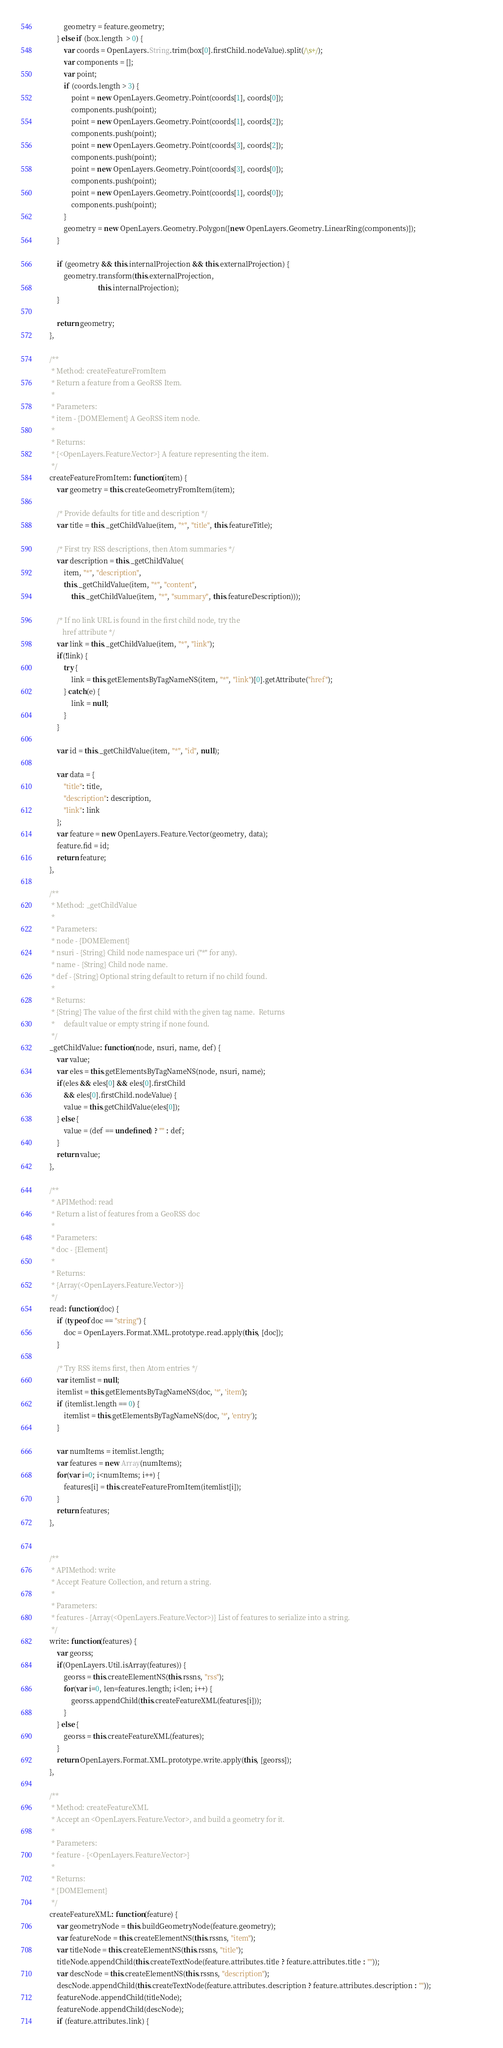<code> <loc_0><loc_0><loc_500><loc_500><_JavaScript_>            geometry = feature.geometry;
        } else if (box.length  > 0) {
            var coords = OpenLayers.String.trim(box[0].firstChild.nodeValue).split(/\s+/);
            var components = [];
            var point;
            if (coords.length > 3) {
                point = new OpenLayers.Geometry.Point(coords[1], coords[0]);
                components.push(point);
                point = new OpenLayers.Geometry.Point(coords[1], coords[2]);
                components.push(point);
                point = new OpenLayers.Geometry.Point(coords[3], coords[2]);
                components.push(point);
                point = new OpenLayers.Geometry.Point(coords[3], coords[0]);
                components.push(point);
                point = new OpenLayers.Geometry.Point(coords[1], coords[0]);
                components.push(point);
            }
            geometry = new OpenLayers.Geometry.Polygon([new OpenLayers.Geometry.LinearRing(components)]);									 
        }
        
        if (geometry && this.internalProjection && this.externalProjection) {
            geometry.transform(this.externalProjection, 
                               this.internalProjection);
        }

        return geometry;
    },        

    /**
     * Method: createFeatureFromItem
     * Return a feature from a GeoRSS Item.
     *
     * Parameters:
     * item - {DOMElement} A GeoRSS item node.
     *
     * Returns:
     * {<OpenLayers.Feature.Vector>} A feature representing the item.
     */
    createFeatureFromItem: function(item) {
        var geometry = this.createGeometryFromItem(item);
     
        /* Provide defaults for title and description */
        var title = this._getChildValue(item, "*", "title", this.featureTitle);
       
        /* First try RSS descriptions, then Atom summaries */
        var description = this._getChildValue(
            item, "*", "description",
            this._getChildValue(item, "*", "content",
                this._getChildValue(item, "*", "summary", this.featureDescription)));

        /* If no link URL is found in the first child node, try the
           href attribute */
        var link = this._getChildValue(item, "*", "link");
        if(!link) {
            try {
                link = this.getElementsByTagNameNS(item, "*", "link")[0].getAttribute("href");
            } catch(e) {
                link = null;
            }
        }

        var id = this._getChildValue(item, "*", "id", null);
        
        var data = {
            "title": title,
            "description": description,
            "link": link
        };
        var feature = new OpenLayers.Feature.Vector(geometry, data);
        feature.fid = id;
        return feature;
    },        
    
    /**
     * Method: _getChildValue
     *
     * Parameters:
     * node - {DOMElement}
     * nsuri - {String} Child node namespace uri ("*" for any).
     * name - {String} Child node name.
     * def - {String} Optional string default to return if no child found.
     *
     * Returns:
     * {String} The value of the first child with the given tag name.  Returns
     *     default value or empty string if none found.
     */
    _getChildValue: function(node, nsuri, name, def) {
        var value;
        var eles = this.getElementsByTagNameNS(node, nsuri, name);
        if(eles && eles[0] && eles[0].firstChild
            && eles[0].firstChild.nodeValue) {
            value = this.getChildValue(eles[0]);
        } else {
            value = (def == undefined) ? "" : def;
        }
        return value;
    },
    
    /**
     * APIMethod: read
     * Return a list of features from a GeoRSS doc
     *
     * Parameters:
     * doc - {Element} 
     *
     * Returns:
     * {Array(<OpenLayers.Feature.Vector>)}
     */
    read: function(doc) {
        if (typeof doc == "string") { 
            doc = OpenLayers.Format.XML.prototype.read.apply(this, [doc]);
        }

        /* Try RSS items first, then Atom entries */
        var itemlist = null;
        itemlist = this.getElementsByTagNameNS(doc, '*', 'item');
        if (itemlist.length == 0) {
            itemlist = this.getElementsByTagNameNS(doc, '*', 'entry');
        }
        
        var numItems = itemlist.length;
        var features = new Array(numItems);
        for(var i=0; i<numItems; i++) {
            features[i] = this.createFeatureFromItem(itemlist[i]);
        }
        return features;
    },
    

    /**
     * APIMethod: write
     * Accept Feature Collection, and return a string. 
     * 
     * Parameters: 
     * features - {Array(<OpenLayers.Feature.Vector>)} List of features to serialize into a string.
     */
    write: function(features) {
        var georss;
        if(OpenLayers.Util.isArray(features)) {
            georss = this.createElementNS(this.rssns, "rss");
            for(var i=0, len=features.length; i<len; i++) {
                georss.appendChild(this.createFeatureXML(features[i]));
            }
        } else {
            georss = this.createFeatureXML(features);
        }
        return OpenLayers.Format.XML.prototype.write.apply(this, [georss]);
    },

    /**
     * Method: createFeatureXML
     * Accept an <OpenLayers.Feature.Vector>, and build a geometry for it.
     * 
     * Parameters:
     * feature - {<OpenLayers.Feature.Vector>} 
     *
     * Returns:
     * {DOMElement}
     */
    createFeatureXML: function(feature) {
        var geometryNode = this.buildGeometryNode(feature.geometry);
        var featureNode = this.createElementNS(this.rssns, "item");
        var titleNode = this.createElementNS(this.rssns, "title");
        titleNode.appendChild(this.createTextNode(feature.attributes.title ? feature.attributes.title : ""));
        var descNode = this.createElementNS(this.rssns, "description");
        descNode.appendChild(this.createTextNode(feature.attributes.description ? feature.attributes.description : ""));
        featureNode.appendChild(titleNode);
        featureNode.appendChild(descNode);
        if (feature.attributes.link) {</code> 